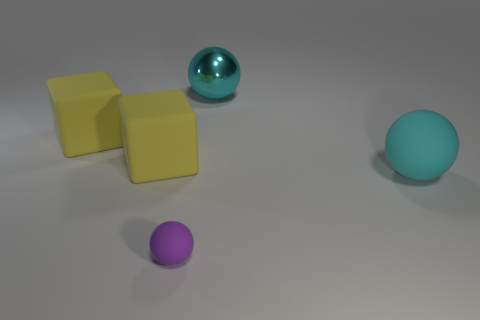Add 3 cyan rubber cylinders. How many objects exist? 8 Subtract all cubes. How many objects are left? 3 Add 4 yellow objects. How many yellow objects are left? 6 Add 4 matte things. How many matte things exist? 8 Subtract 0 yellow spheres. How many objects are left? 5 Subtract all blocks. Subtract all cyan things. How many objects are left? 1 